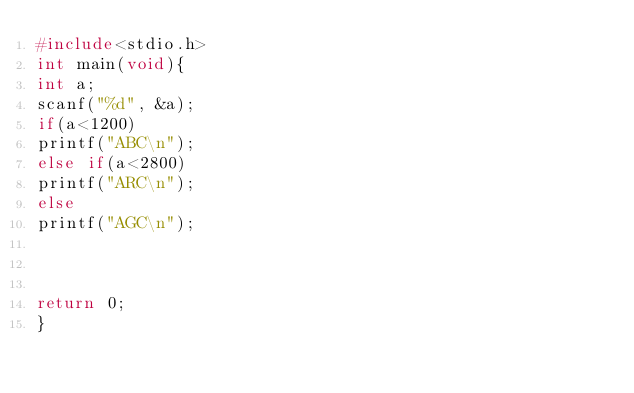<code> <loc_0><loc_0><loc_500><loc_500><_C_>#include<stdio.h>
int main(void){
int a;
scanf("%d", &a);
if(a<1200)
printf("ABC\n");
else if(a<2800)
printf("ARC\n");
else
printf("AGC\n");



return 0;
}</code> 